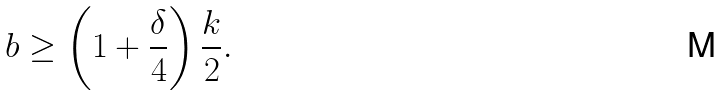Convert formula to latex. <formula><loc_0><loc_0><loc_500><loc_500>b \geq \left ( 1 + \frac { \delta } 4 \right ) \frac { k } { 2 } .</formula> 